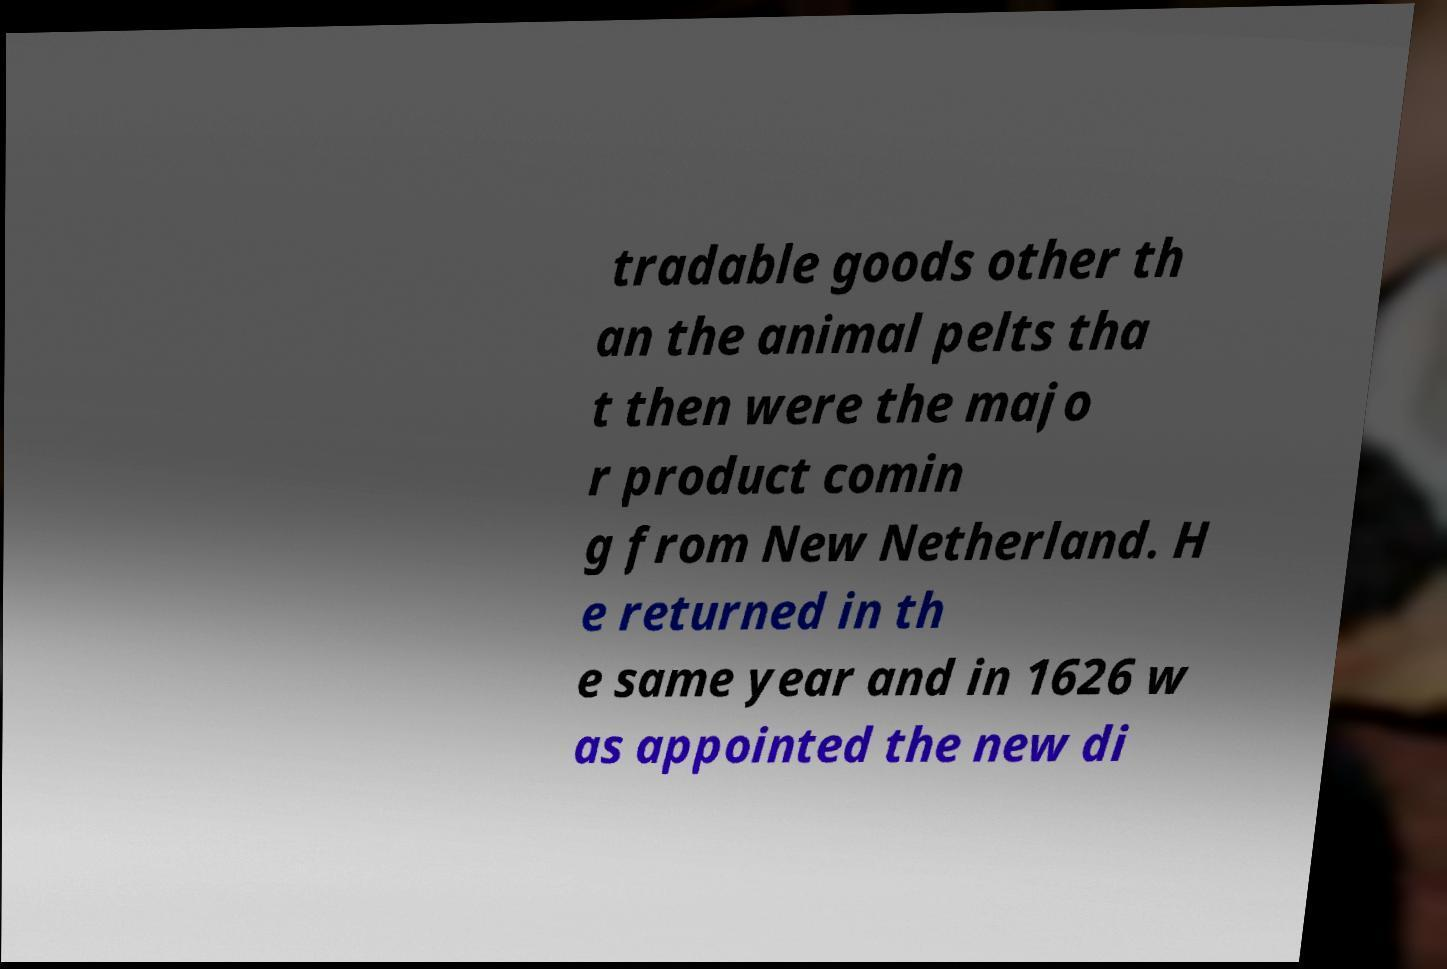I need the written content from this picture converted into text. Can you do that? tradable goods other th an the animal pelts tha t then were the majo r product comin g from New Netherland. H e returned in th e same year and in 1626 w as appointed the new di 